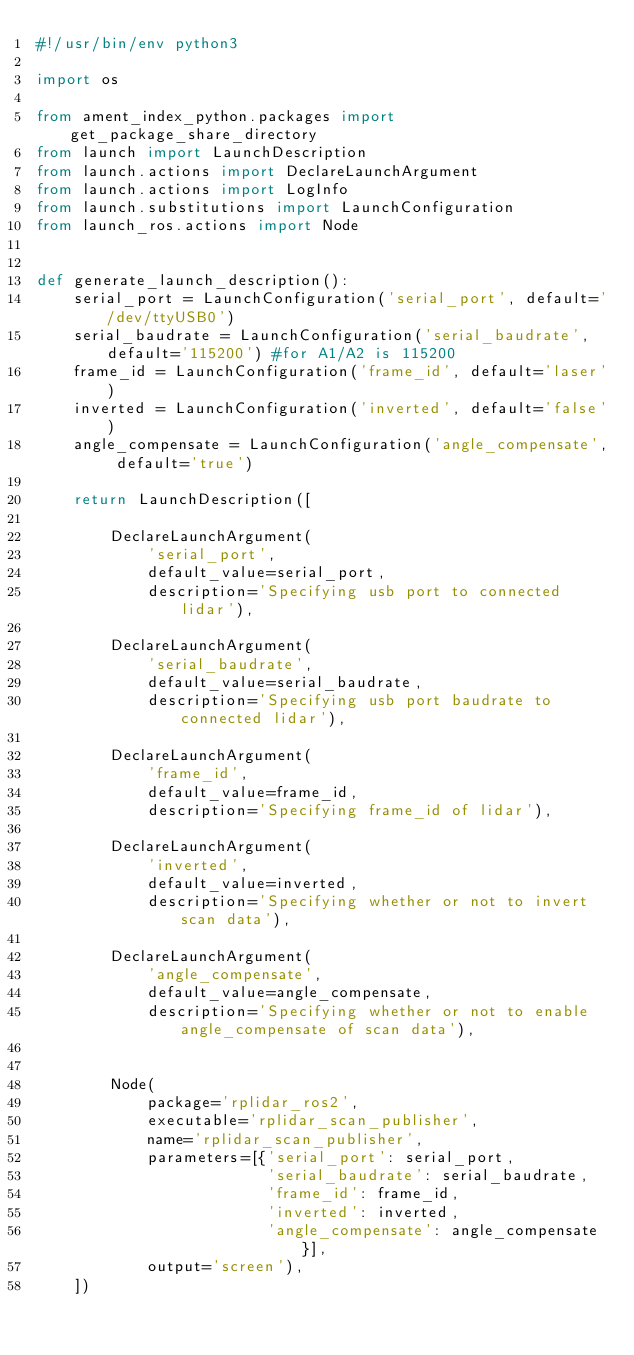Convert code to text. <code><loc_0><loc_0><loc_500><loc_500><_Python_>#!/usr/bin/env python3

import os

from ament_index_python.packages import get_package_share_directory
from launch import LaunchDescription
from launch.actions import DeclareLaunchArgument
from launch.actions import LogInfo
from launch.substitutions import LaunchConfiguration
from launch_ros.actions import Node


def generate_launch_description():
    serial_port = LaunchConfiguration('serial_port', default='/dev/ttyUSB0')
    serial_baudrate = LaunchConfiguration('serial_baudrate', default='115200') #for A1/A2 is 115200
    frame_id = LaunchConfiguration('frame_id', default='laser')
    inverted = LaunchConfiguration('inverted', default='false')
    angle_compensate = LaunchConfiguration('angle_compensate', default='true')

    return LaunchDescription([

        DeclareLaunchArgument(
            'serial_port',
            default_value=serial_port,
            description='Specifying usb port to connected lidar'),

        DeclareLaunchArgument(
            'serial_baudrate',
            default_value=serial_baudrate,
            description='Specifying usb port baudrate to connected lidar'),
        
        DeclareLaunchArgument(
            'frame_id',
            default_value=frame_id,
            description='Specifying frame_id of lidar'),

        DeclareLaunchArgument(
            'inverted',
            default_value=inverted,
            description='Specifying whether or not to invert scan data'),

        DeclareLaunchArgument(
            'angle_compensate',
            default_value=angle_compensate,
            description='Specifying whether or not to enable angle_compensate of scan data'),


        Node(
            package='rplidar_ros2',
            executable='rplidar_scan_publisher',
            name='rplidar_scan_publisher',
            parameters=[{'serial_port': serial_port, 
                         'serial_baudrate': serial_baudrate, 
                         'frame_id': frame_id,
                         'inverted': inverted, 
                         'angle_compensate': angle_compensate}],
            output='screen'),
    ])

</code> 